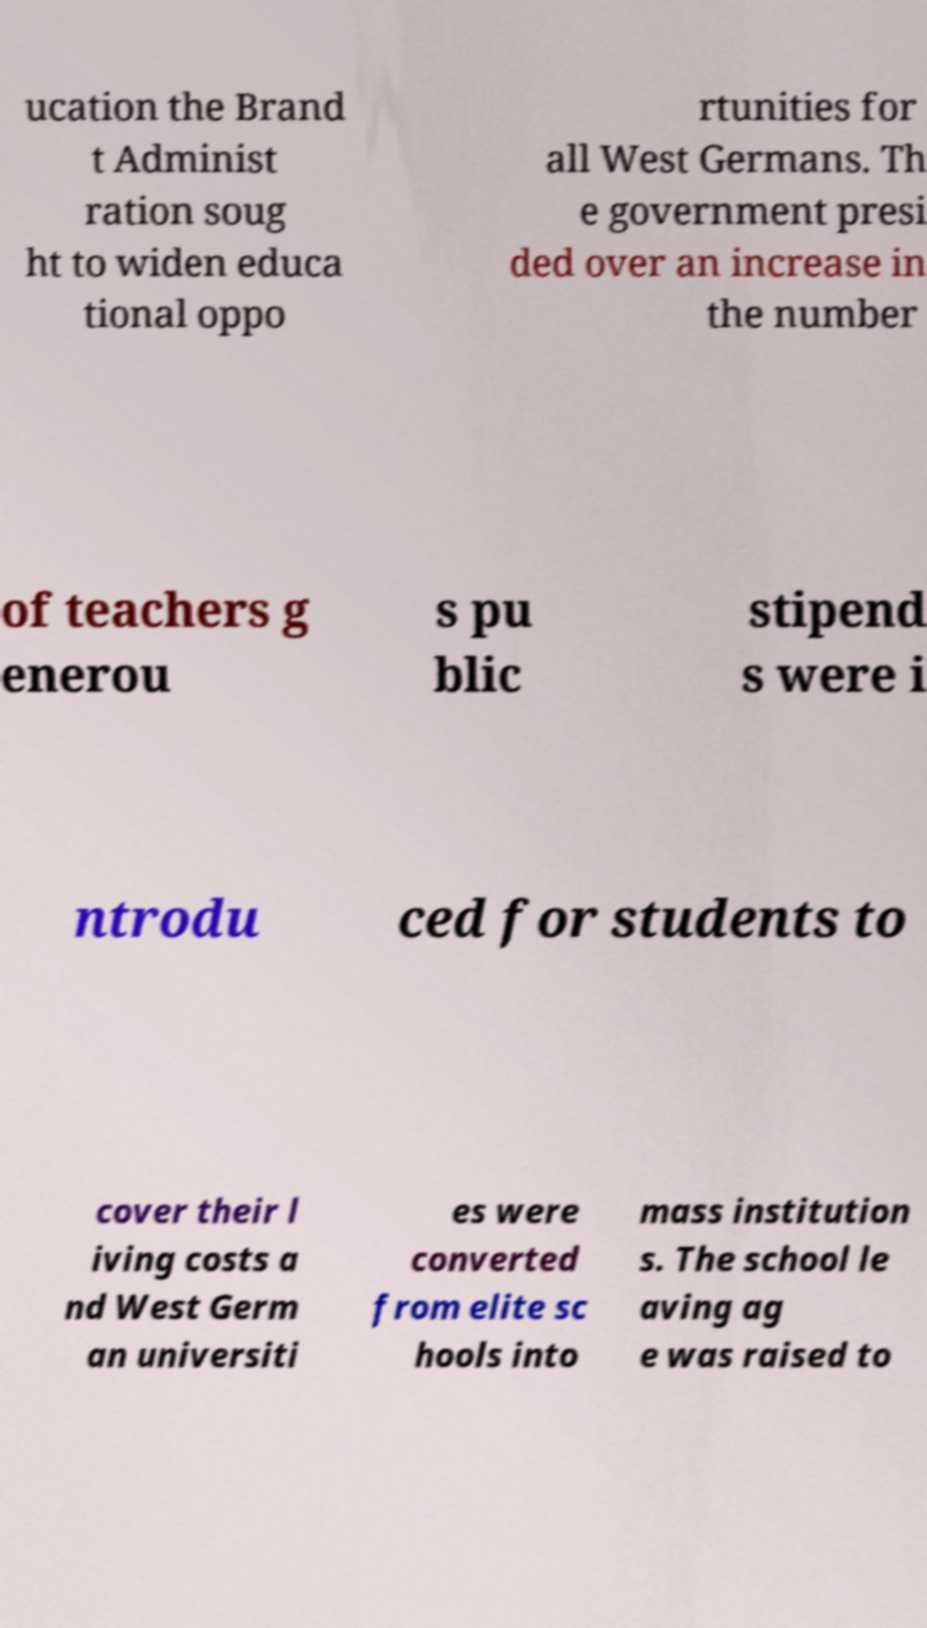Could you extract and type out the text from this image? ucation the Brand t Administ ration soug ht to widen educa tional oppo rtunities for all West Germans. Th e government presi ded over an increase in the number of teachers g enerou s pu blic stipend s were i ntrodu ced for students to cover their l iving costs a nd West Germ an universiti es were converted from elite sc hools into mass institution s. The school le aving ag e was raised to 